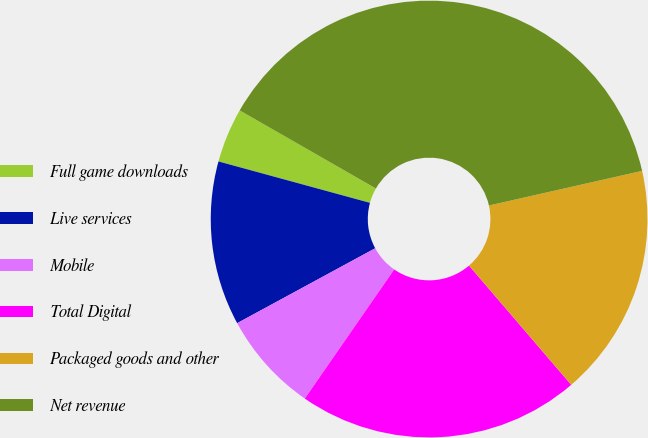Convert chart to OTSL. <chart><loc_0><loc_0><loc_500><loc_500><pie_chart><fcel>Full game downloads<fcel>Live services<fcel>Mobile<fcel>Total Digital<fcel>Packaged goods and other<fcel>Net revenue<nl><fcel>4.04%<fcel>12.16%<fcel>7.45%<fcel>20.92%<fcel>17.26%<fcel>38.18%<nl></chart> 